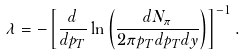Convert formula to latex. <formula><loc_0><loc_0><loc_500><loc_500>\lambda = - \left [ \frac { d } { d p _ { T } } \ln \left ( \frac { d N _ { \pi } } { 2 \pi p _ { T } d p _ { T } d y } \right ) \right ] ^ { - 1 } .</formula> 